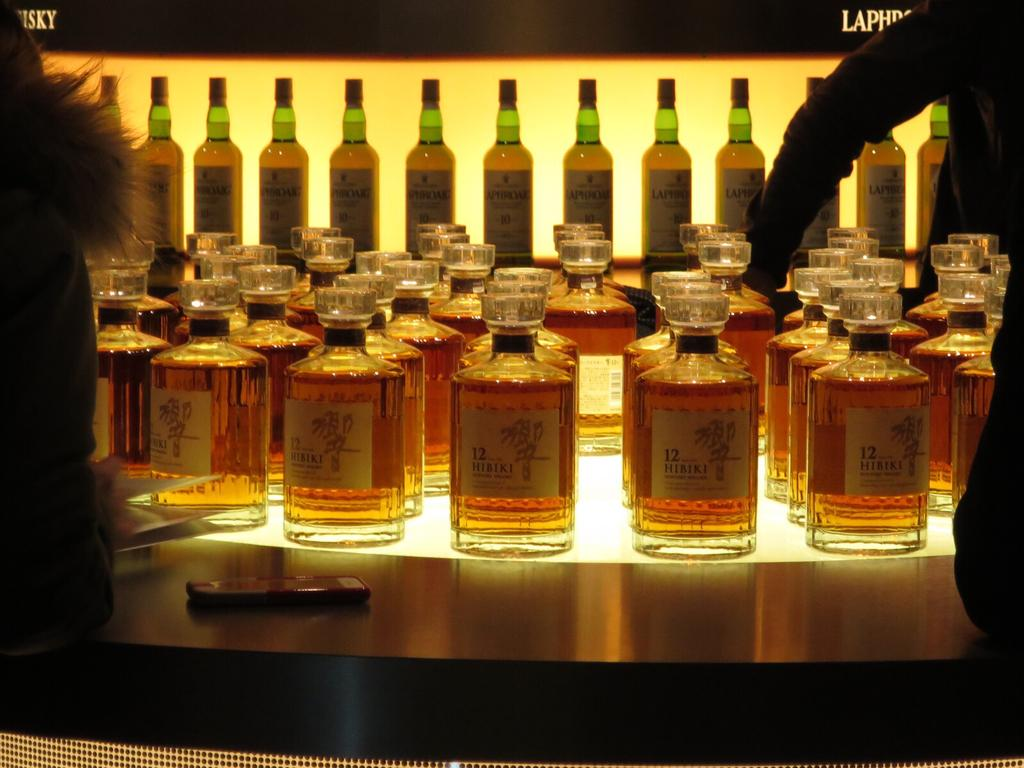What is the main subject of the image? The main subject of the image is a rack with different bottles. Can you describe the contents of the rack? The rack contains different bottles. Are there any human figures in the image? Yes, there are partial parts of humans on both the right and left sides of the image. What type of cream can be seen on the seashore in the image? There is no seashore or cream present in the image; it features a rack with different bottles and partial parts of humans. 